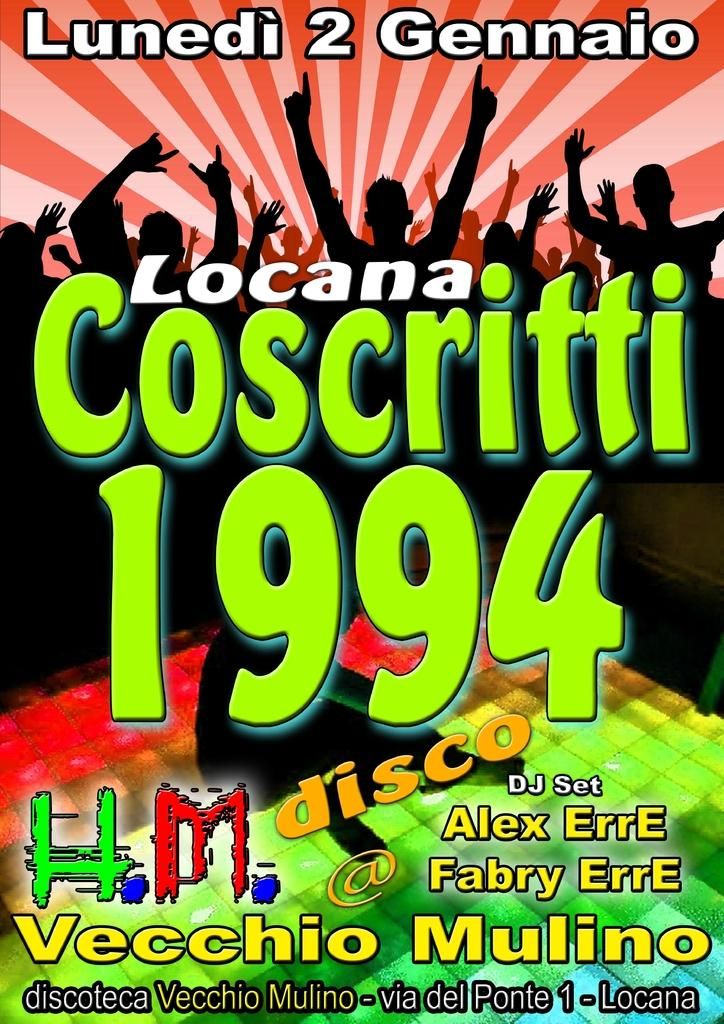<image>
Summarize the visual content of the image. The poster advertises a disco with a DJ called Alex Erre and Fabry Erre. 